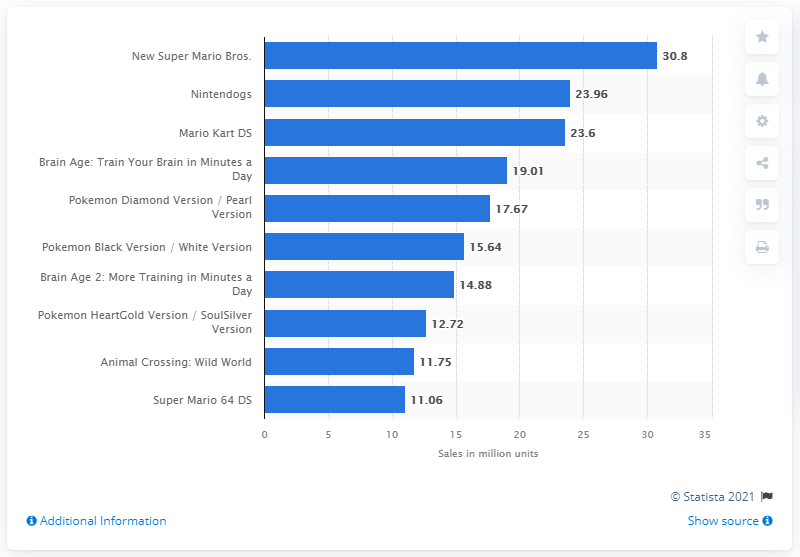Give some essential details in this illustration. In March 2021, Nintendo DS units were sold in quantity of 30.8. 